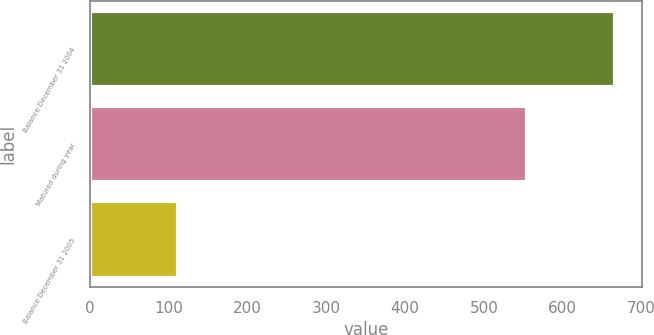Convert chart to OTSL. <chart><loc_0><loc_0><loc_500><loc_500><bar_chart><fcel>Balance December 31 2004<fcel>Matured during year<fcel>Balance December 31 2005<nl><fcel>667<fcel>555<fcel>112<nl></chart> 